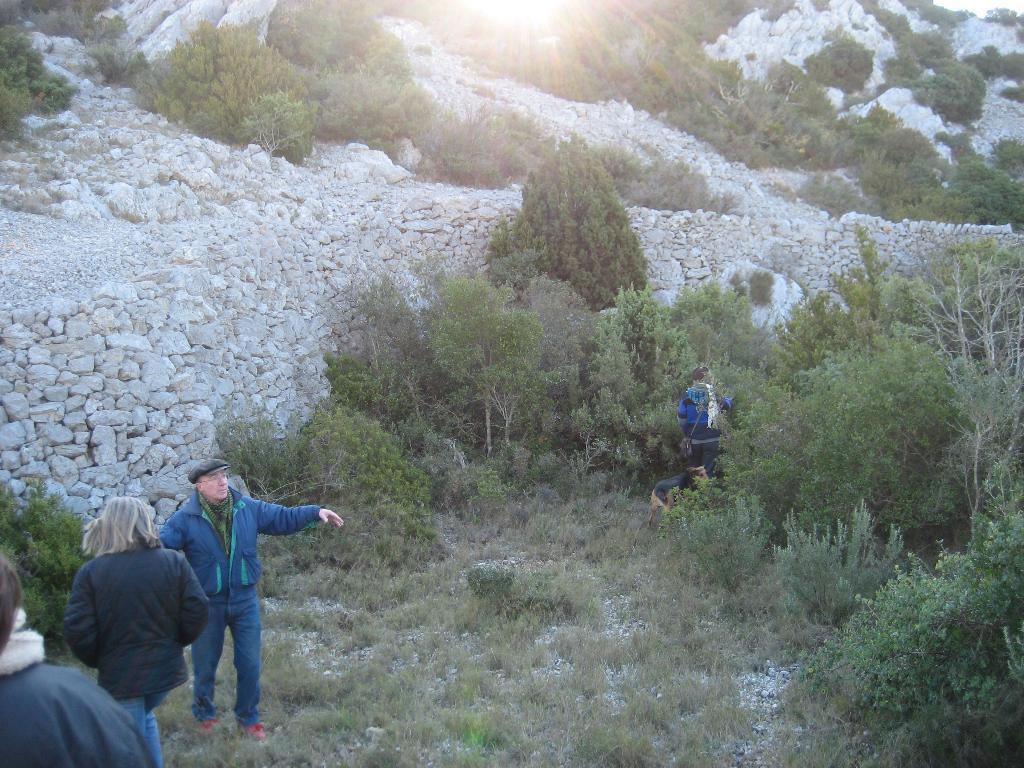How would you summarize this image in a sentence or two? In the left bottom, we see three people are standing. At the bottom, we see the grass. In the middle, we see a person is standing. Beside the person, we see the trees. In the middle of the picture, we see the stones. There are trees and stones in the background. We even see the sun. 